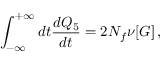Convert formula to latex. <formula><loc_0><loc_0><loc_500><loc_500>\int _ { - \infty } ^ { + \infty } d t { \frac { d Q _ { 5 } } { d t } } = 2 N _ { f } \nu [ G ] \, ,</formula> 